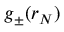<formula> <loc_0><loc_0><loc_500><loc_500>g _ { \pm } ( r _ { N } )</formula> 